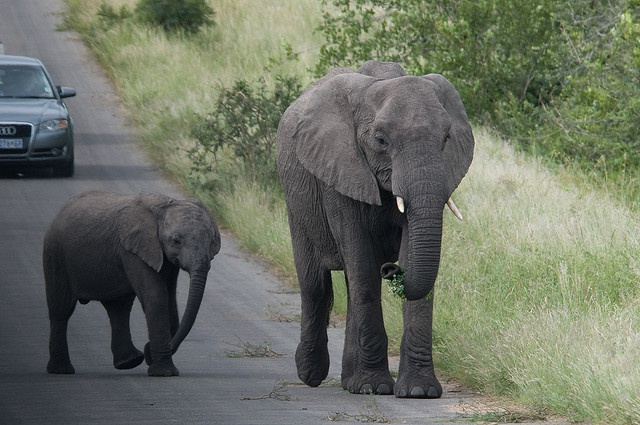Describe the objects in this image and their specific colors. I can see elephant in gray, black, and darkgray tones, elephant in gray and black tones, and car in gray, black, and darkgray tones in this image. 